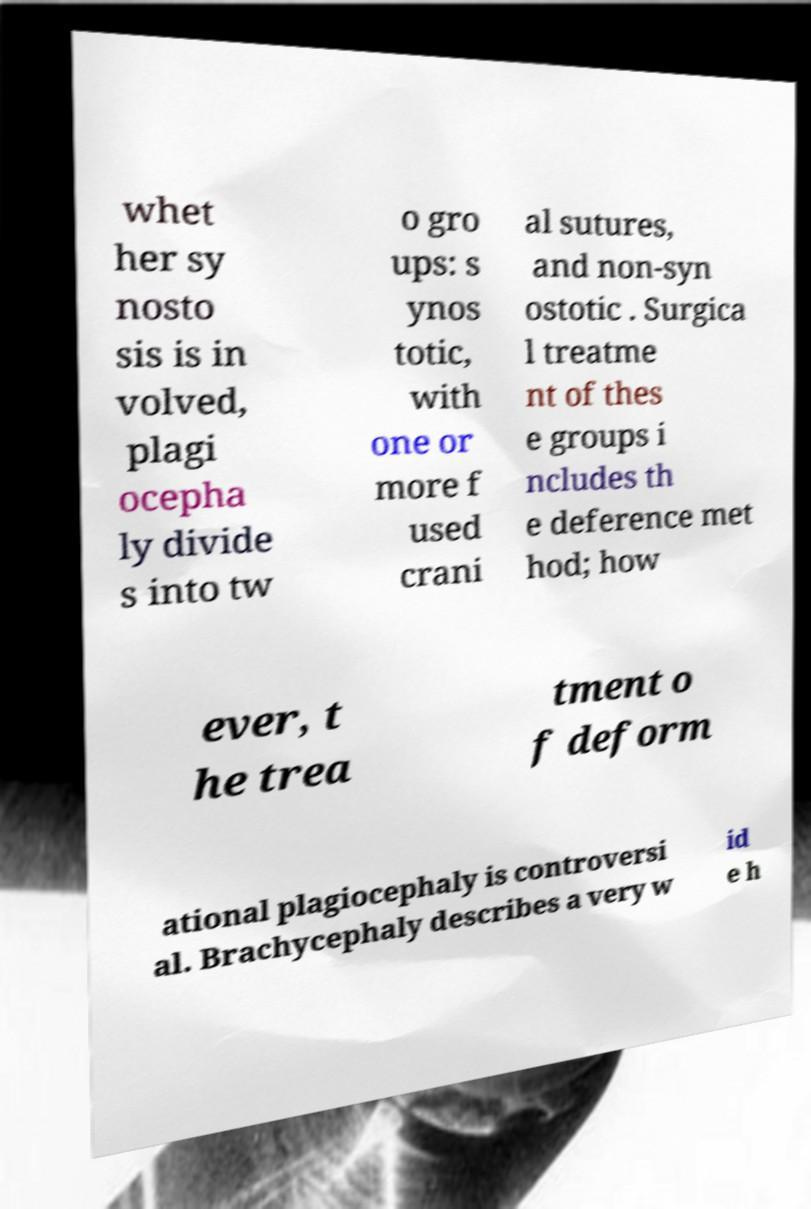What messages or text are displayed in this image? I need them in a readable, typed format. whet her sy nosto sis is in volved, plagi ocepha ly divide s into tw o gro ups: s ynos totic, with one or more f used crani al sutures, and non-syn ostotic . Surgica l treatme nt of thes e groups i ncludes th e deference met hod; how ever, t he trea tment o f deform ational plagiocephaly is controversi al. Brachycephaly describes a very w id e h 